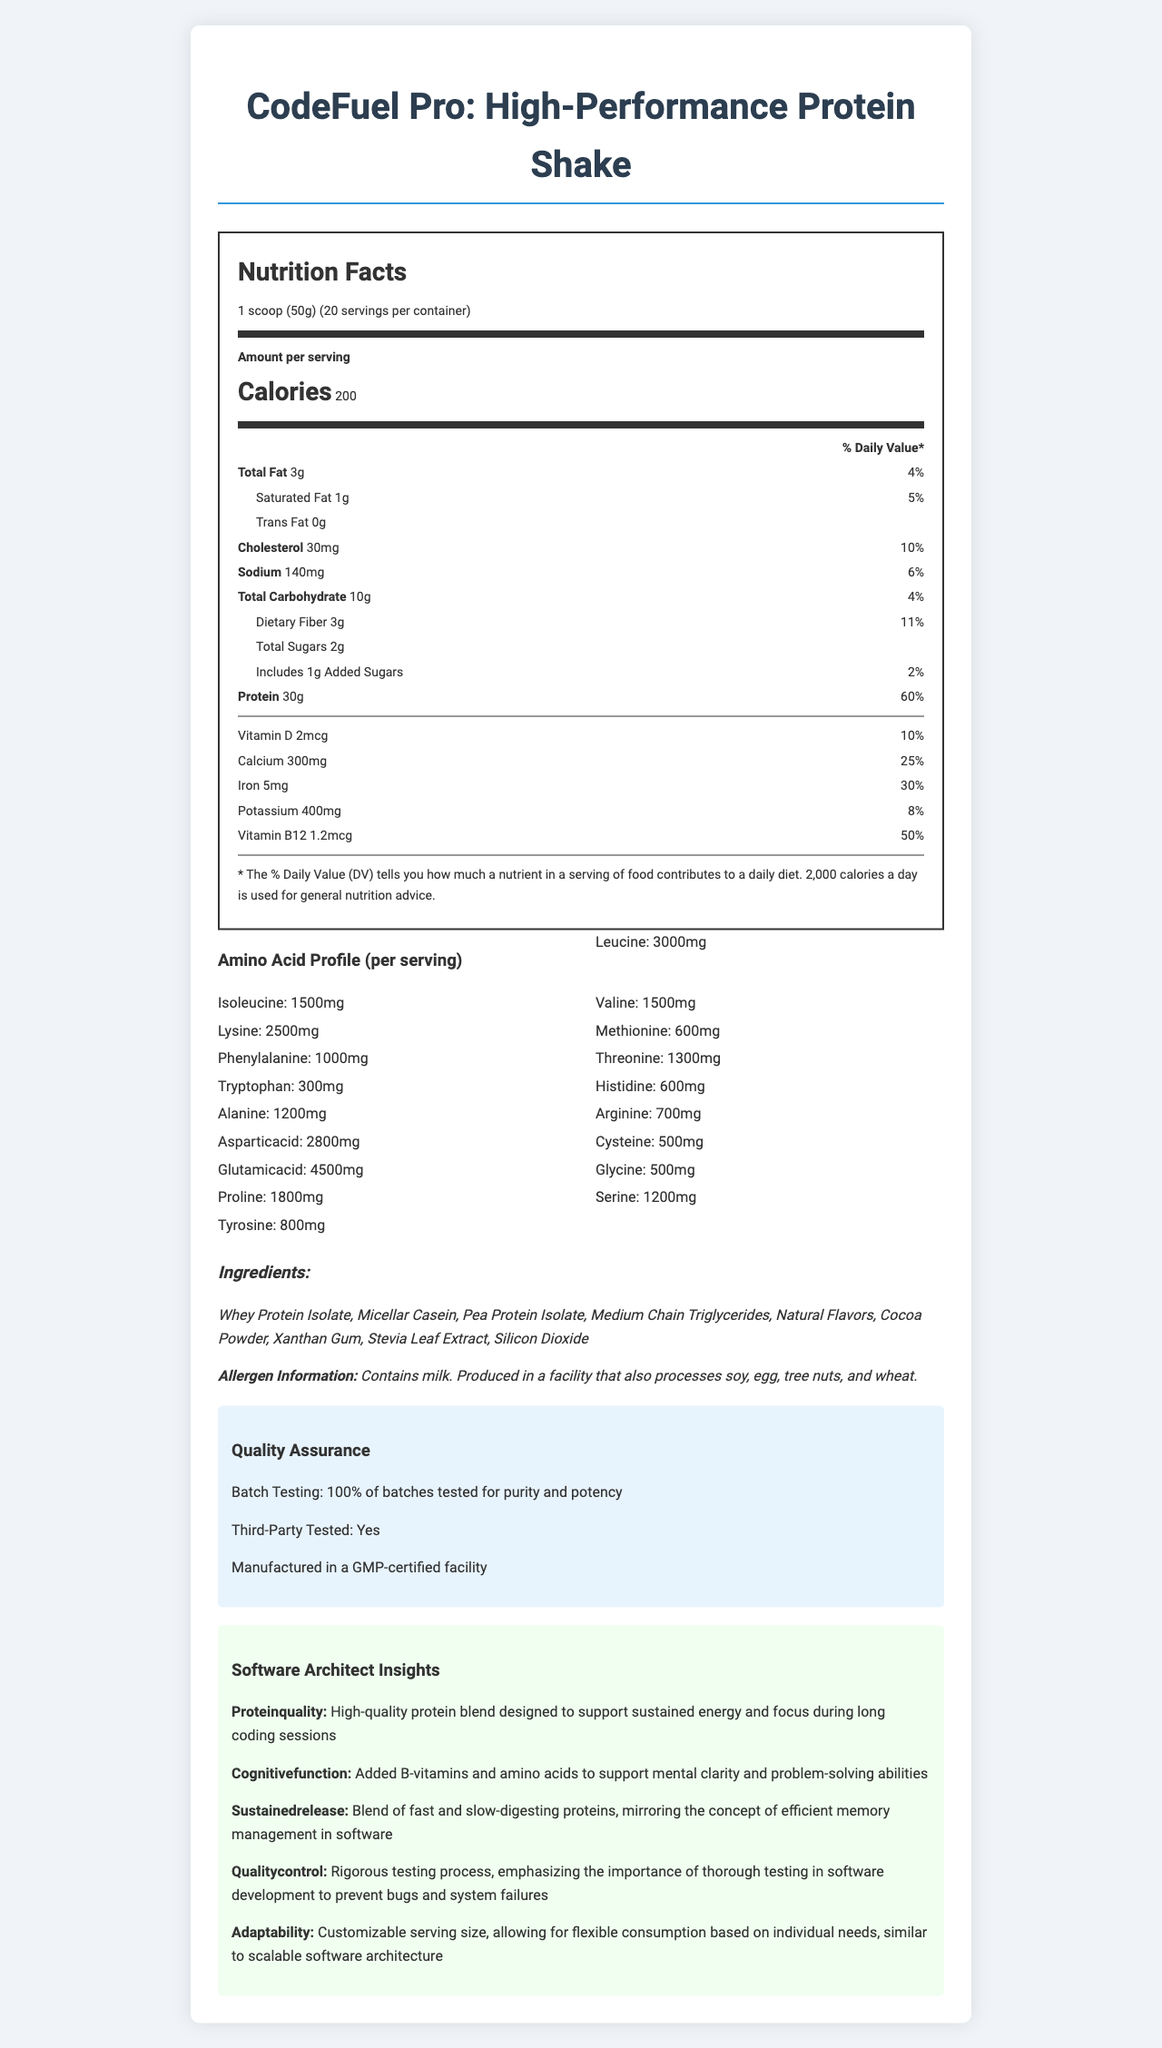what is the name of the product? The name of the product is prominently displayed at the top of the document.
Answer: CodeFuel Pro: High-Performance Protein Shake what is the serving size of the product? The serving size is noted in the "Nutrition Facts" section.
Answer: 1 scoop (50g) how many calories are in one serving? The "Calories" amount per serving is specified in the "Nutrition Facts" section.
Answer: 200 what is the amount of total fat per serving? The amount of total fat is listed in the "Nutrition Facts" section under "Total Fat".
Answer: 3g what is the percentage of daily value for dietary fiber per serving? The daily value percentage for dietary fiber is given in the document under "Dietary Fiber".
Answer: 11% what is the amount of protein per serving? A. 10g B. 20g C. 30g D. 40g The amount of protein per serving is clearly listed as 30g in the "Nutrition Facts" section.
Answer: C. 30g which of the following amino acids has the highest amount per serving? i. Glutamic Acid ii. Valine iii. Lysine iv. Methionine The amount of Glutamic Acid per serving is 4500mg, which is the highest compared to Valine (1500mg), Lysine (2500mg), and Methionine (600mg).
Answer: i. Glutamic Acid is the product third-party tested? The Quality Assurance section mentions that the product is third-party tested.
Answer: Yes does the product contain any allergens? The "Allergen Information" section states that the product contains milk.
Answer: Yes, it contains milk provide a summary of the document. The document offers a comprehensive overview of the product, including its nutritional composition, quality assurance processes, and specific benefits for software architects. The insights section highlights the blend's design to support sustained energy, mental clarity, and adaptable consumption.
Answer: The document is a detailed nutrition facts label for "CodeFuel Pro: High-Performance Protein Shake." It includes information on serving size, calorie content, macronutrient breakdown, amino acid profile, ingredients, allergen information, and quality assurance details. The document also features insights tailored for software architects, emphasizing high-quality protein, cognitive function support, sustained release, rigorous testing, and adaptability. what is the amount of phenylalanine per serving? The amount of phenylalanine is listed under the "Amino Acid Profile" section.
Answer: 1000mg what flavors are used in the product? The ingredient list includes "Natural Flavors" and "Cocoa Powder".
Answer: Natural Flavors, Cocoa Powder can you determine the cost of the product from this document? The document does not provide any pricing information.
Answer: Not enough information how many servings are in one container? The number of servings per container is noted as 20 in the "Nutrition Facts" section.
Answer: 20 what is the percentage of the daily value for vitamin B12 per serving? The daily value percentage for vitamin B12 is shown as 50% in the "Nutrition Facts" section.
Answer: 50% which ingredient is used as a sweetener? The ingredient list includes "Stevia Leaf Extract," which is commonly used as a natural sweetener.
Answer: Stevia Leaf Extract 